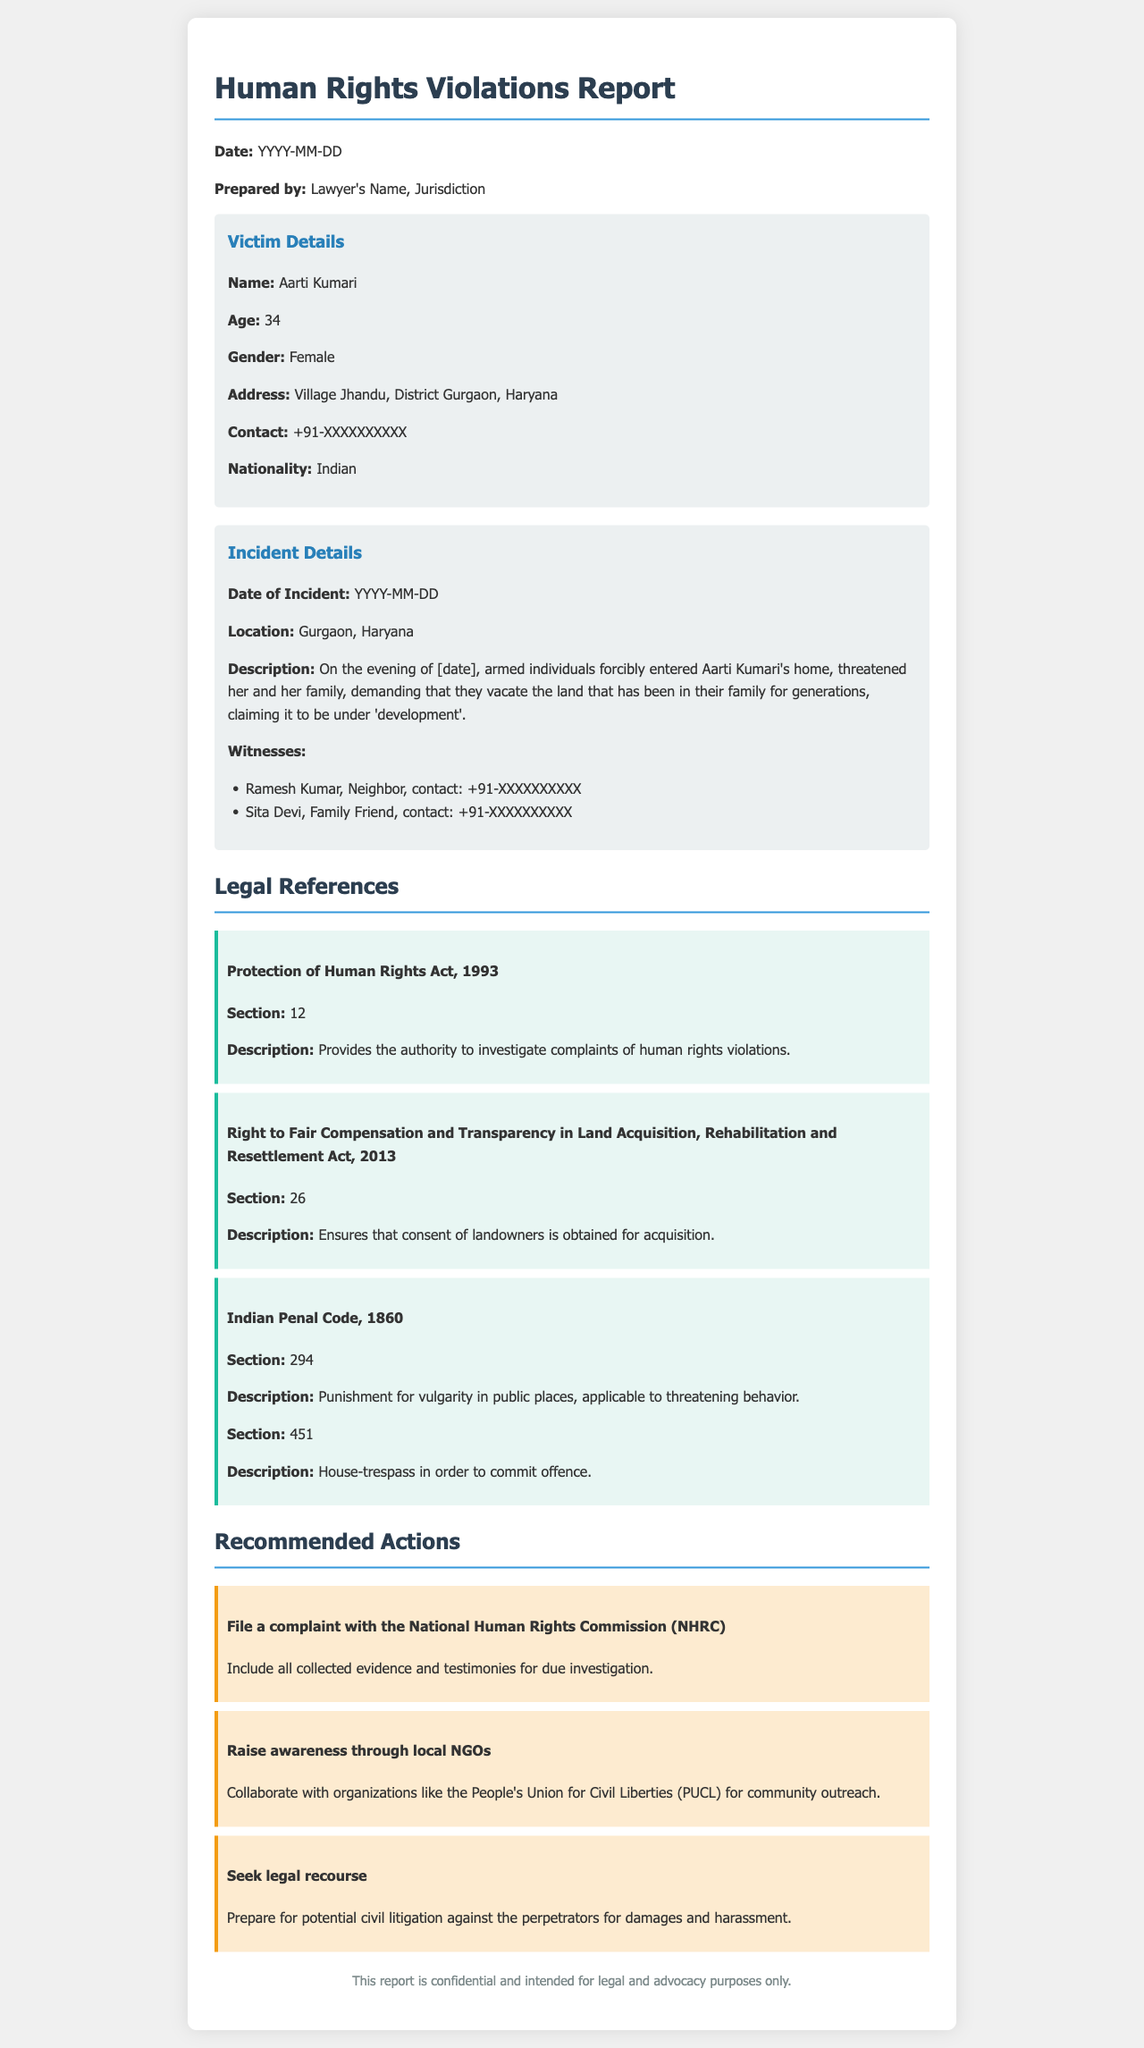What is the victim's name? The victim's name is explicitly mentioned in the Victim Details section of the document.
Answer: Aarti Kumari What is the age of the victim? The age of the victim is clearly stated in the Victim Details section.
Answer: 34 What date should the report be prepared? The report requires a date that is specified as a placeholder in the document.
Answer: YYYY-MM-DD What is one suggested action for advocacy? The recommended actions section lists various actions stakeholders can take, one of which is noted.
Answer: File a complaint with the National Human Rights Commission Which Act ensures consent for land acquisition? This legal reference is found in the Legal References section specifying an Act that pertains to land rights.
Answer: Right to Fair Compensation and Transparency in Land Acquisition, Rehabilitation and Resettlement Act, 2013 What type of trespass is mentioned in the Indian Penal Code? The document mentions specific offenses categorized in the legal references, one of which is identified.
Answer: House-trespass in order to commit offence What is the location of the incident? The geographic details of the incident are provided under the Incident Details section.
Answer: Gurgaon, Haryana What is the contact number for one of the witnesses? The contact information of witnesses is listed in the Incident Details section of the document.
Answer: +91-XXXXXXXXXX What does the footer state about the report? The footer provides information about the confidentiality of the report intended for a specific purpose.
Answer: This report is confidential and intended for legal and advocacy purposes only 